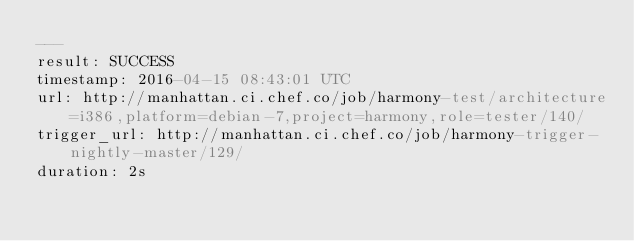Convert code to text. <code><loc_0><loc_0><loc_500><loc_500><_YAML_>---
result: SUCCESS
timestamp: 2016-04-15 08:43:01 UTC
url: http://manhattan.ci.chef.co/job/harmony-test/architecture=i386,platform=debian-7,project=harmony,role=tester/140/
trigger_url: http://manhattan.ci.chef.co/job/harmony-trigger-nightly-master/129/
duration: 2s
</code> 